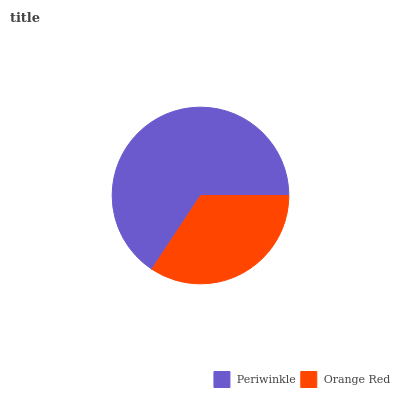Is Orange Red the minimum?
Answer yes or no. Yes. Is Periwinkle the maximum?
Answer yes or no. Yes. Is Orange Red the maximum?
Answer yes or no. No. Is Periwinkle greater than Orange Red?
Answer yes or no. Yes. Is Orange Red less than Periwinkle?
Answer yes or no. Yes. Is Orange Red greater than Periwinkle?
Answer yes or no. No. Is Periwinkle less than Orange Red?
Answer yes or no. No. Is Periwinkle the high median?
Answer yes or no. Yes. Is Orange Red the low median?
Answer yes or no. Yes. Is Orange Red the high median?
Answer yes or no. No. Is Periwinkle the low median?
Answer yes or no. No. 